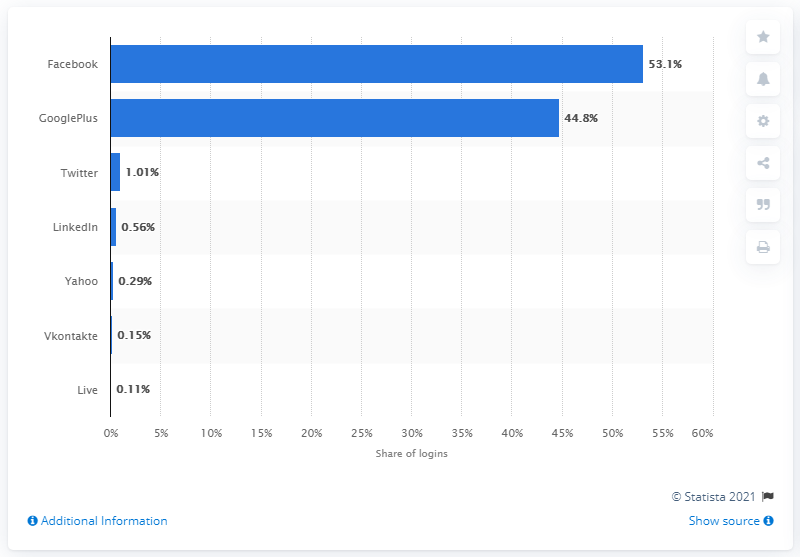List a handful of essential elements in this visual. According to the data, 53.1% of social logins were made through a Facebook account. 